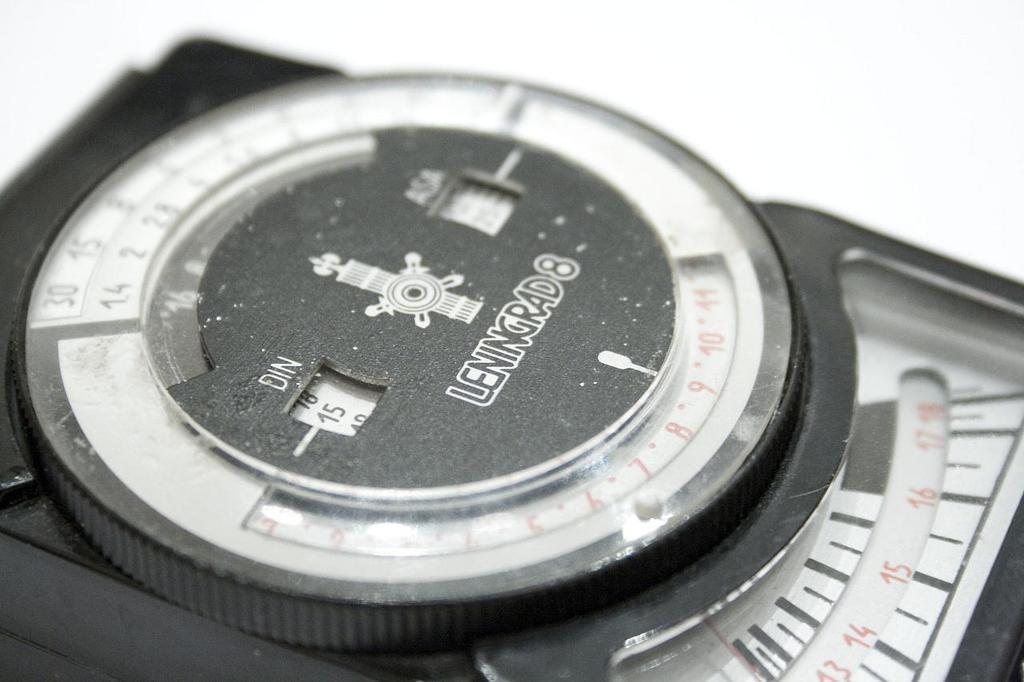<image>
Give a short and clear explanation of the subsequent image. A brand name LENGRAD8 wristwatch sitting on a table. 